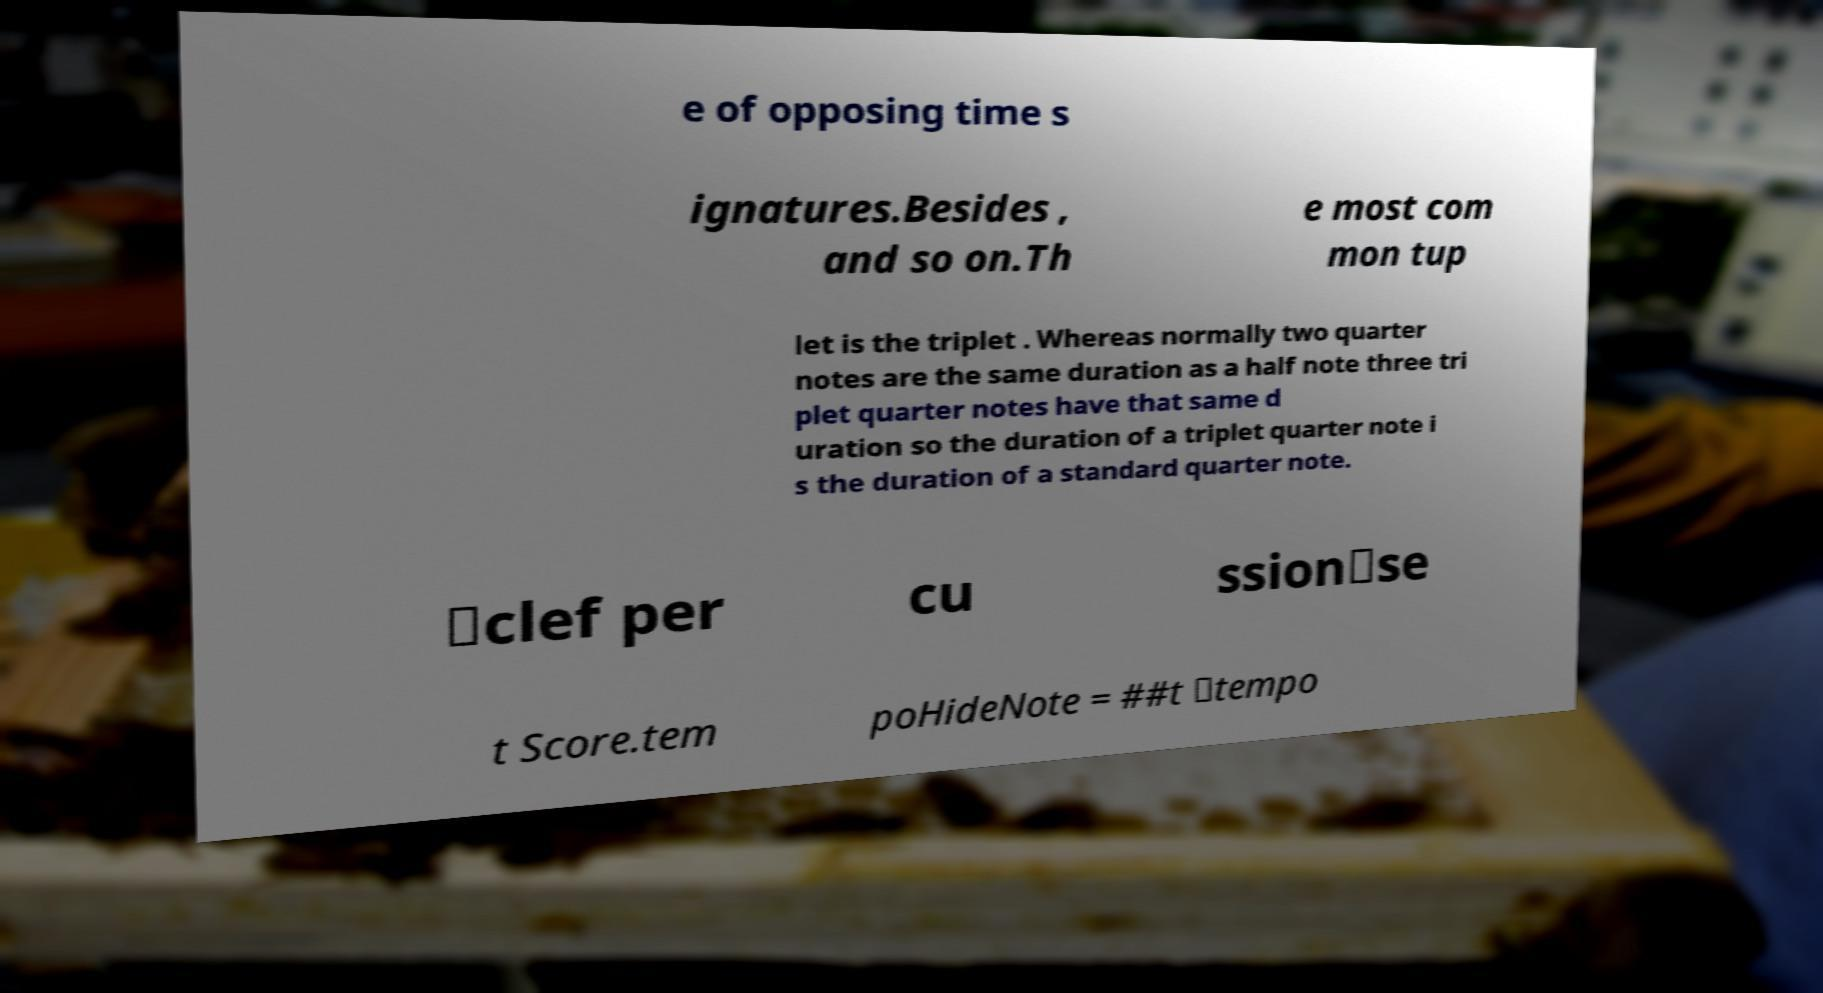Could you assist in decoding the text presented in this image and type it out clearly? e of opposing time s ignatures.Besides , and so on.Th e most com mon tup let is the triplet . Whereas normally two quarter notes are the same duration as a half note three tri plet quarter notes have that same d uration so the duration of a triplet quarter note i s the duration of a standard quarter note. \clef per cu ssion\se t Score.tem poHideNote = ##t \tempo 